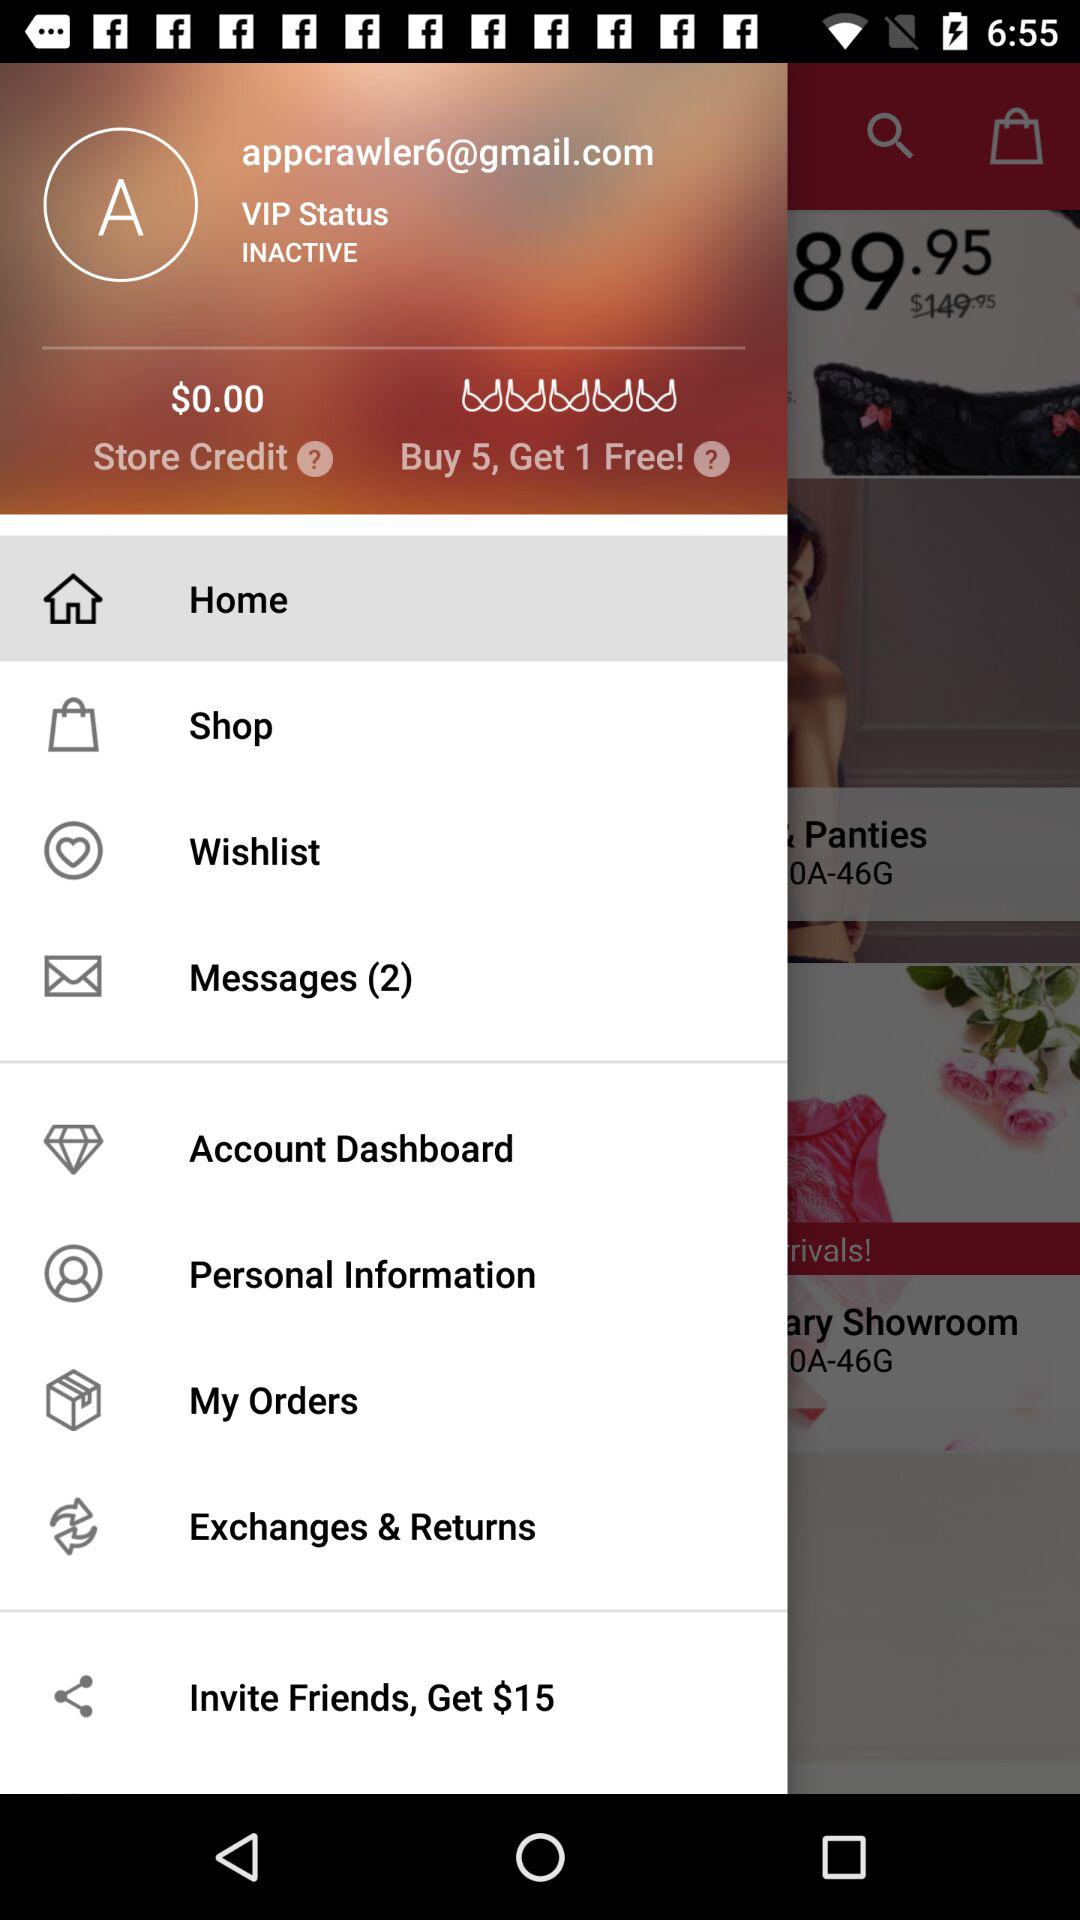How much $ do we get by inviting friends? By inviting friends, you will get $15. 